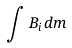<formula> <loc_0><loc_0><loc_500><loc_500>\int { B } _ { i } d m</formula> 